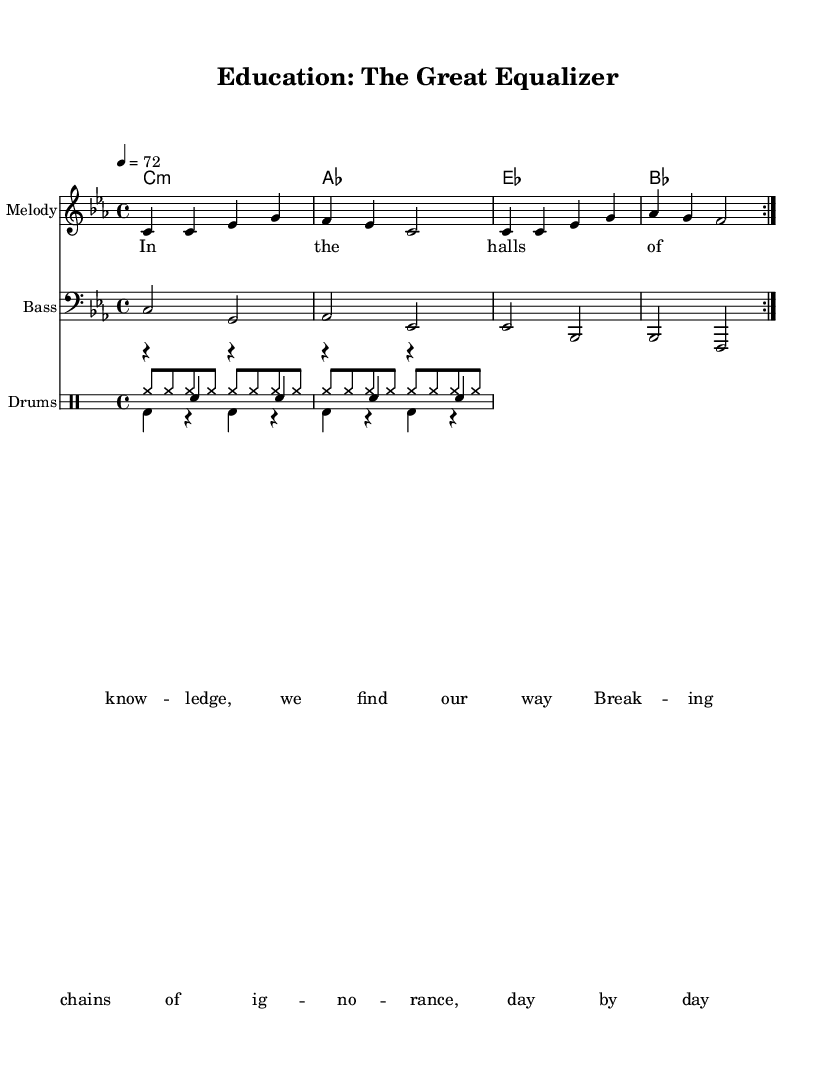What is the key signature of this music? The key signature is C minor, which has three flats (B♭, E♭, and A♭). You can determine this from the initial section of the music sheet where the key is indicated.
Answer: C minor What is the time signature of the piece? The time signature is 4/4, meaning there are four beats in each measure and the quarter note gets one beat. This is indicated at the beginning of the sheet music.
Answer: 4/4 What is the tempo marking for this piece? The tempo marking is quarter note equals 72, which indicates the speed at which the piece should be played. This information is provided next to the tempo indication in the score.
Answer: 72 What type of rhythmic pattern is used for the drum hi-hat section? The drum hi-hat section uses eighth note rhythms, which is evident from the consistent pattern of eight hits in the measure. This can be recognized by the notation in the drumming staff.
Answer: Eighth notes How does the melody connect to the theme of education? The melody's lyrics focus on themes of knowledge and breaking chains of ignorance. By analyzing the text in the lyrics section and seeing how the melody supports these words, we grasp the connection to education's role in social mobility.
Answer: Knowledge What is the primary chord progression used in this piece? The primary chord progression consists of C minor, A♭ major, E♭ major, and B♭ major chords, which can be seen in the chord names section accompanying the melody.
Answer: C minor, A♭, E♭, B♭ What unique element is found in the structure of conscious reggae tracks? A unique element is the socially conscious lyrics that address themes like education and social mobility. This thematic focus is specified in the lyrics and reflects the message that reggae often aims to convey.
Answer: Socially conscious lyrics 